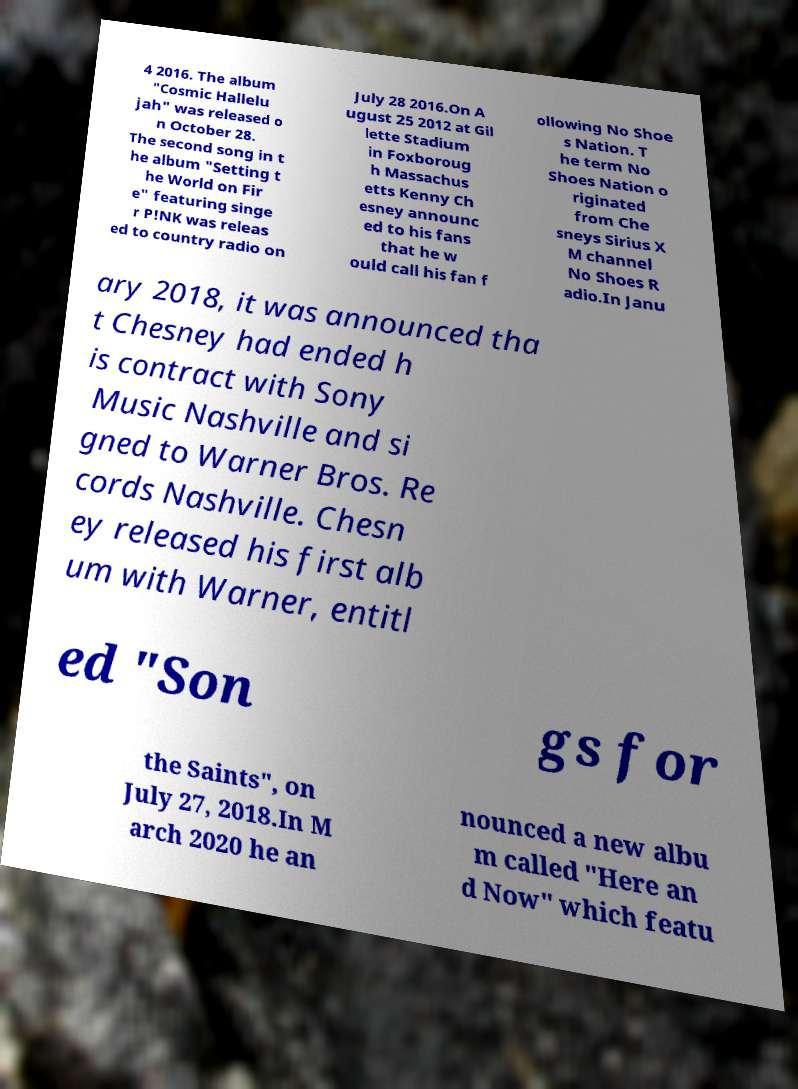Can you accurately transcribe the text from the provided image for me? 4 2016. The album "Cosmic Hallelu jah" was released o n October 28. The second song in t he album "Setting t he World on Fir e" featuring singe r P!NK was releas ed to country radio on July 28 2016.On A ugust 25 2012 at Gil lette Stadium in Foxboroug h Massachus etts Kenny Ch esney announc ed to his fans that he w ould call his fan f ollowing No Shoe s Nation. T he term No Shoes Nation o riginated from Che sneys Sirius X M channel No Shoes R adio.In Janu ary 2018, it was announced tha t Chesney had ended h is contract with Sony Music Nashville and si gned to Warner Bros. Re cords Nashville. Chesn ey released his first alb um with Warner, entitl ed "Son gs for the Saints", on July 27, 2018.In M arch 2020 he an nounced a new albu m called "Here an d Now" which featu 